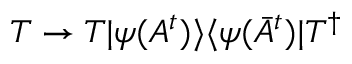<formula> <loc_0><loc_0><loc_500><loc_500>T \rightarrow T | \psi ( A ^ { t } ) \rangle \langle \psi ( \bar { A } ^ { t } ) | T ^ { \dagger }</formula> 